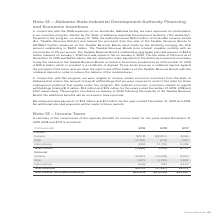According to Adtran's financial document, Which periods are included in the summary of the components of the expense (benefit) for income taxes in the table? the years ended December 31, 2019, 2018 and 2017. The document states: "g $1.2 million, $1.4 million and $1.5 million for the years ended December 31, 2019, 2018 and 2017, respectively. This program concluded on January 2,..." Also, What was the expense (benefit) of the current Federal component in 2019? According to the financial document, $(518) (in thousands). The relevant text states: "Federal $(518) $(8,001) $466..." Also, What is the expense (benefit) for current International component? According to the financial document, (282) (in thousands). The relevant text states: "International (282) 11,705 6,458..." Also, can you calculate: What was the change in current state expense (benefit) between 2018 and 2019? Based on the calculation: -1,065-(-476), the result is -589 (in thousands). This is based on the information: "State (1,065) (476) (150) State (1,065) (476) (150)..." The key data points involved are: 1,065, 476. Also, can you calculate: What was the change in deferred federal expense (benefit) between 2018 and 2019? Based on the calculation: 24,801-(-14,448), the result is 39249 (in thousands). This is based on the information: "Federal 24,801 (14,448) 8,024 Federal 24,801 (14,448) 8,024..." The key data points involved are: 14,448, 24,801. Also, can you calculate: What is the percentage change in total income tax expense (benefit) between 2018 and 2019? To answer this question, I need to perform calculations using the financial data. The calculation is: ($28,205-(-$14,029))/-$14,029, which equals -301.05 (percentage). This is based on the information: "Total Income Tax Expense (Benefit) $28,205 $(14,029) $20,847 Total Income Tax Expense (Benefit) $28,205 $(14,029) $20,847..." The key data points involved are: 14,029, 28,205. 